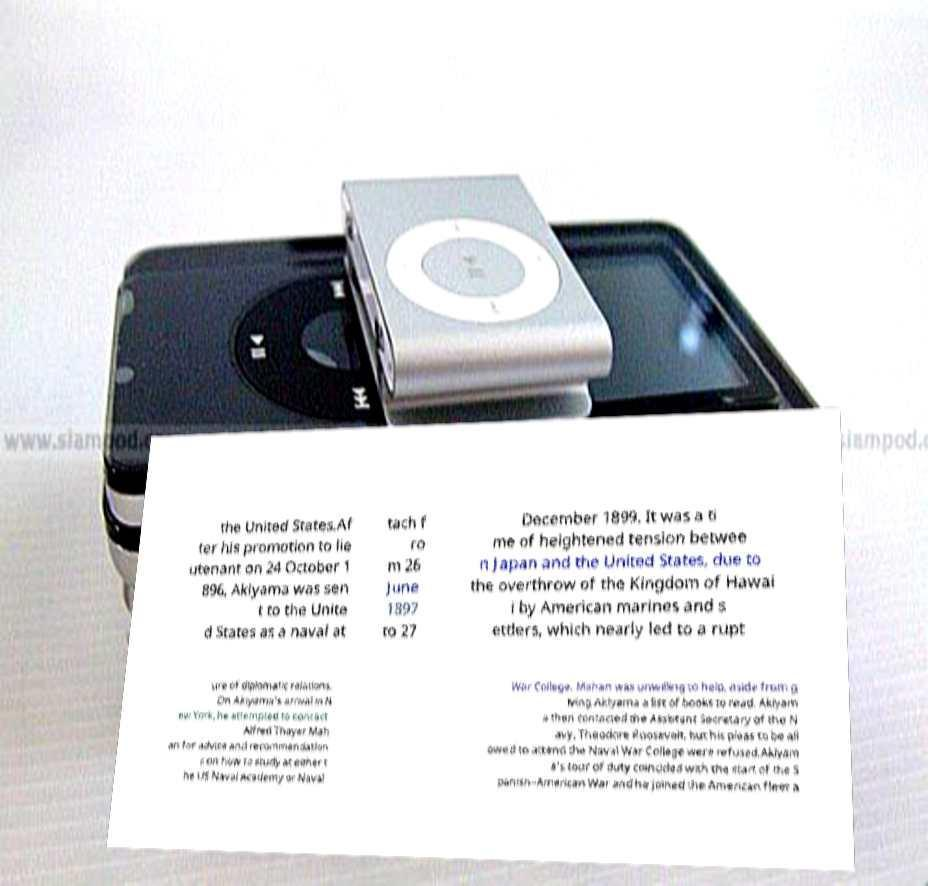Please read and relay the text visible in this image. What does it say? the United States.Af ter his promotion to lie utenant on 24 October 1 896, Akiyama was sen t to the Unite d States as a naval at tach f ro m 26 June 1897 to 27 December 1899. It was a ti me of heightened tension betwee n Japan and the United States, due to the overthrow of the Kingdom of Hawai i by American marines and s ettlers, which nearly led to a rupt ure of diplomatic relations. On Akiyama's arrival in N ew York, he attempted to contact Alfred Thayer Mah an for advice and recommendation s on how to study at either t he US Naval Academy or Naval War College. Mahan was unwilling to help, aside from g iving Akiyama a list of books to read. Akiyam a then contacted the Assistant Secretary of the N avy, Theodore Roosevelt, but his pleas to be all owed to attend the Naval War College were refused.Akiyam a’s tour of duty coincided with the start of the S panish–American War and he joined the American fleet a 